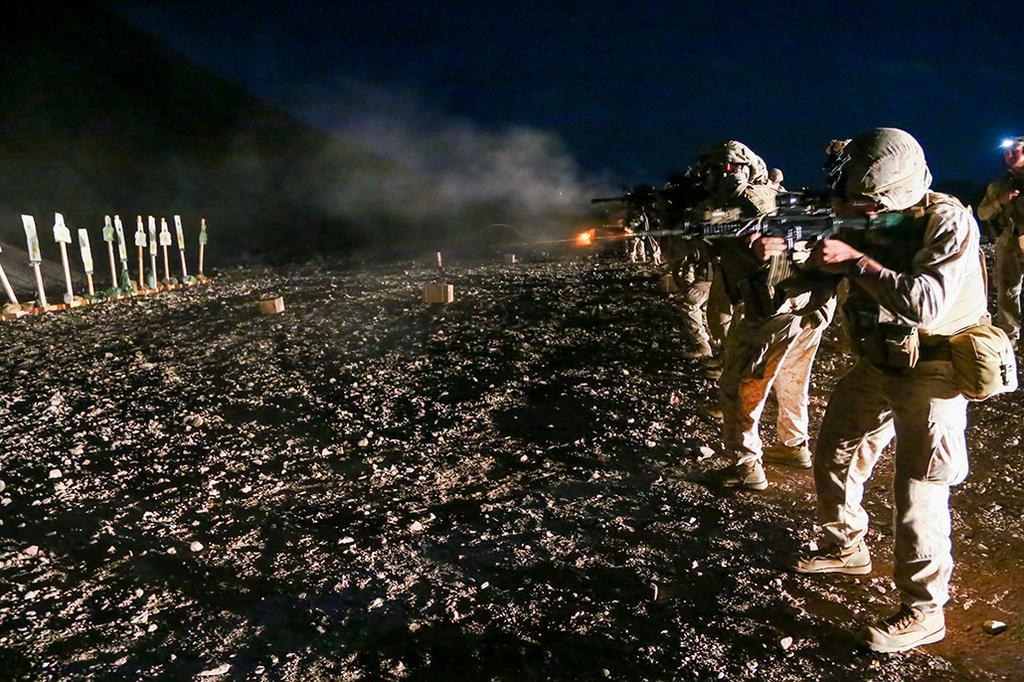Please provide a concise description of this image. In this image there is a ground in middle of this image and there are some persons standing on the right side of this image and they are holding weapons. There are some objects kept on the left side of this image and there is a sky on the top of this image. 